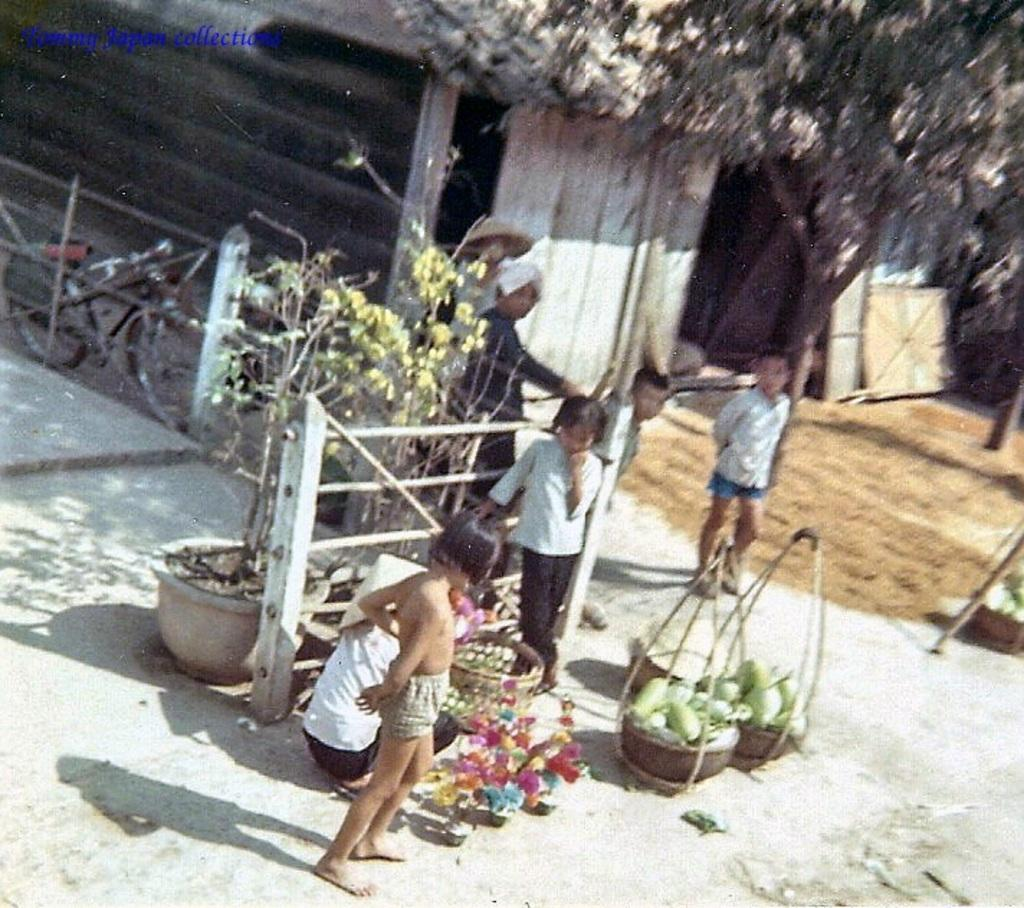What type of food items are in the baskets in the image? There are vegetables in baskets in the image. What can be seen on the path in the image? There are flower pots on the path in the image. What mode of transportation is visible in the image? There are bicycles visible in the image. What is visible in the background of the image? There is a house and a tree in the background of the image. Where is the pan located in the image? There is no pan present in the image. What type of expansion is taking place in the image? There is no expansion taking place in the image; it is a static scene. 